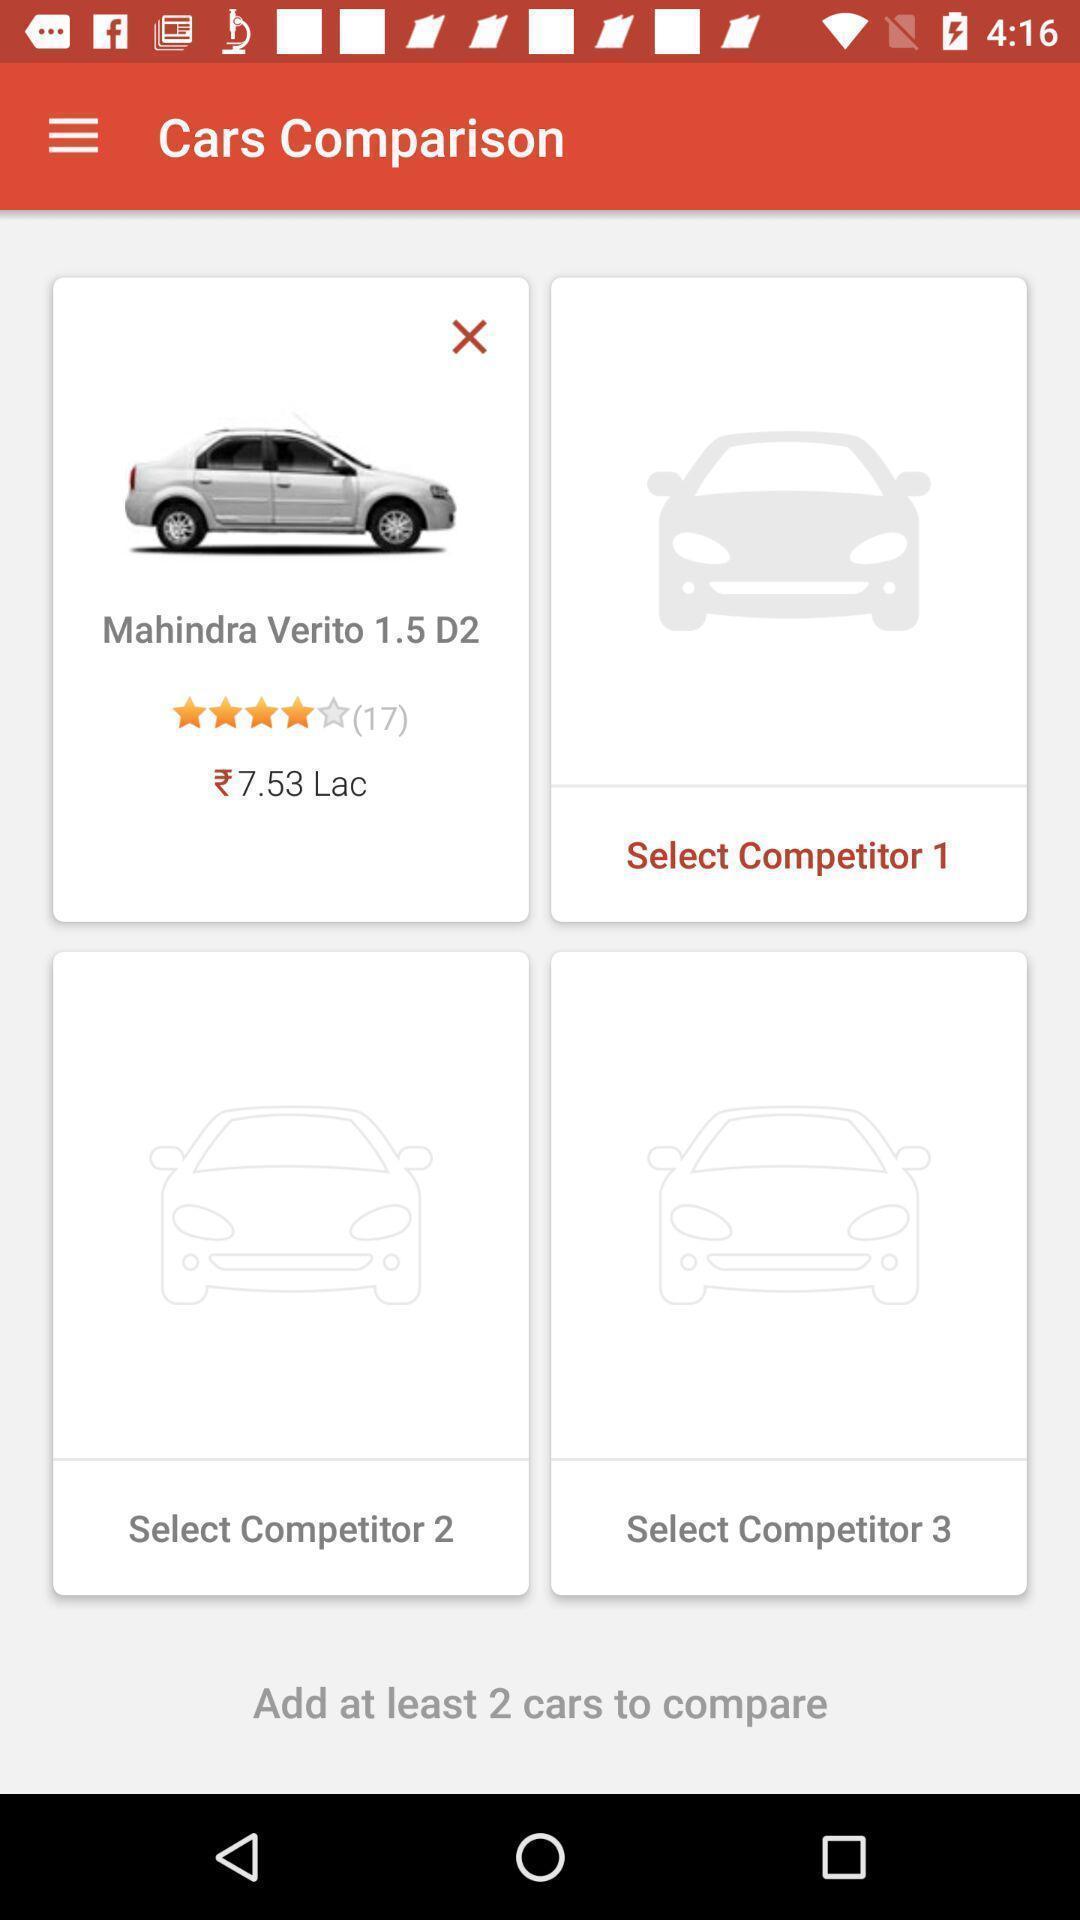What can you discern from this picture? Page displaying information. 